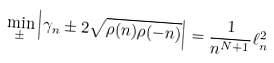<formula> <loc_0><loc_0><loc_500><loc_500>\min _ { \pm } \left | \gamma _ { n } \pm 2 \sqrt { \rho ( n ) \rho ( - n ) } \right | = \frac { 1 } { n ^ { N + 1 } } \ell _ { n } ^ { 2 }</formula> 